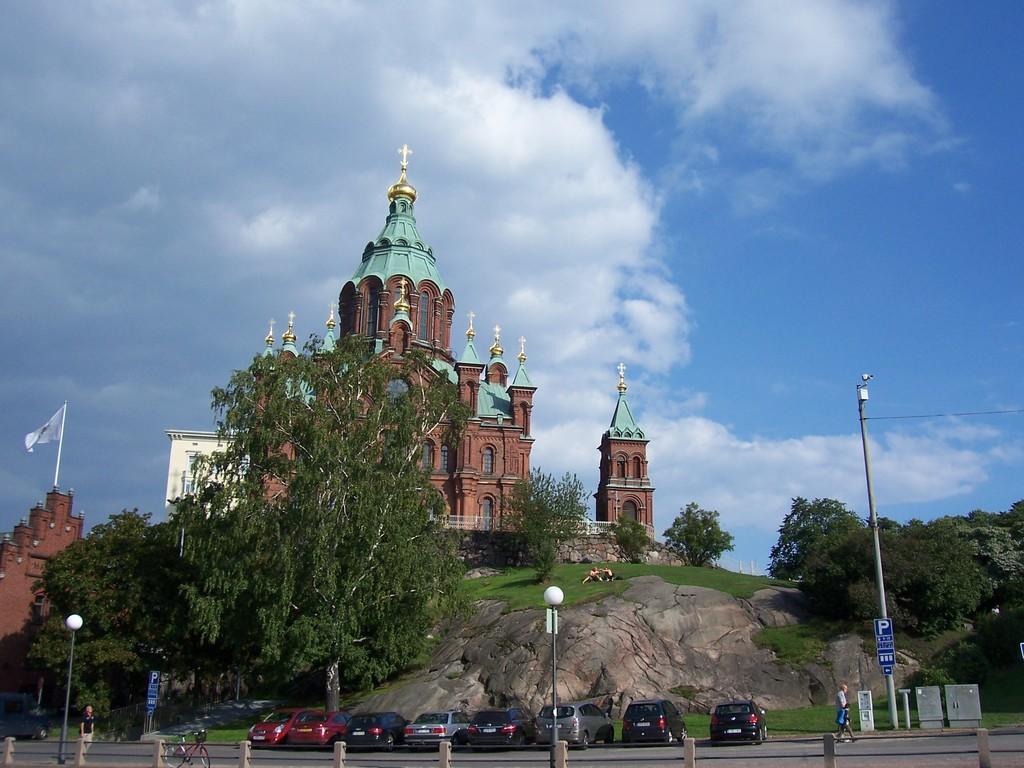In one or two sentences, can you explain what this image depicts? In this image, we can see buildings, trees, poles, a flag, rock, boards, a bicycle and there are some vehicles on the road and we can see some people. At the top, there are clouds in the sky. 